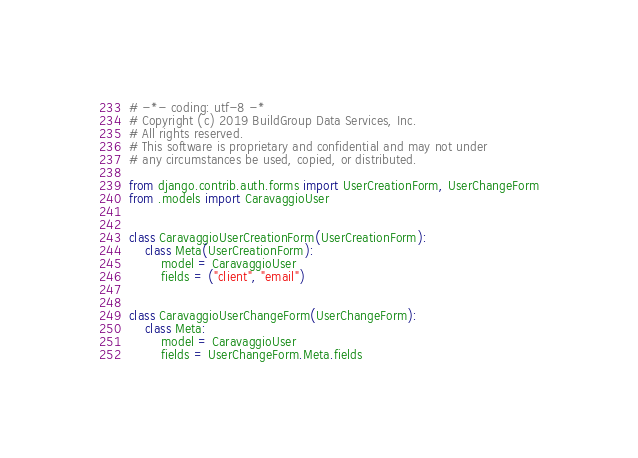Convert code to text. <code><loc_0><loc_0><loc_500><loc_500><_Python_># -*- coding: utf-8 -*
# Copyright (c) 2019 BuildGroup Data Services, Inc.
# All rights reserved.
# This software is proprietary and confidential and may not under
# any circumstances be used, copied, or distributed.

from django.contrib.auth.forms import UserCreationForm, UserChangeForm
from .models import CaravaggioUser


class CaravaggioUserCreationForm(UserCreationForm):
    class Meta(UserCreationForm):
        model = CaravaggioUser
        fields = ("client", "email")


class CaravaggioUserChangeForm(UserChangeForm):
    class Meta:
        model = CaravaggioUser
        fields = UserChangeForm.Meta.fields
</code> 